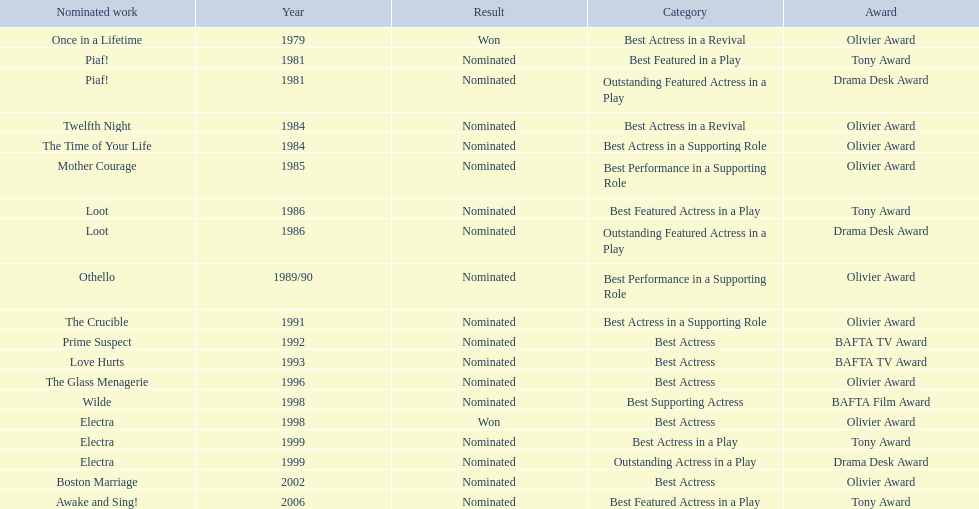What were all of the nominated works with zoe wanamaker? Once in a Lifetime, Piaf!, Piaf!, Twelfth Night, The Time of Your Life, Mother Courage, Loot, Loot, Othello, The Crucible, Prime Suspect, Love Hurts, The Glass Menagerie, Wilde, Electra, Electra, Electra, Boston Marriage, Awake and Sing!. And in which years were these nominations? 1979, 1981, 1981, 1984, 1984, 1985, 1986, 1986, 1989/90, 1991, 1992, 1993, 1996, 1998, 1998, 1999, 1999, 2002, 2006. Which categories was she nominated for in 1984? Best Actress in a Revival. And for which work was this nomination? Twelfth Night. 